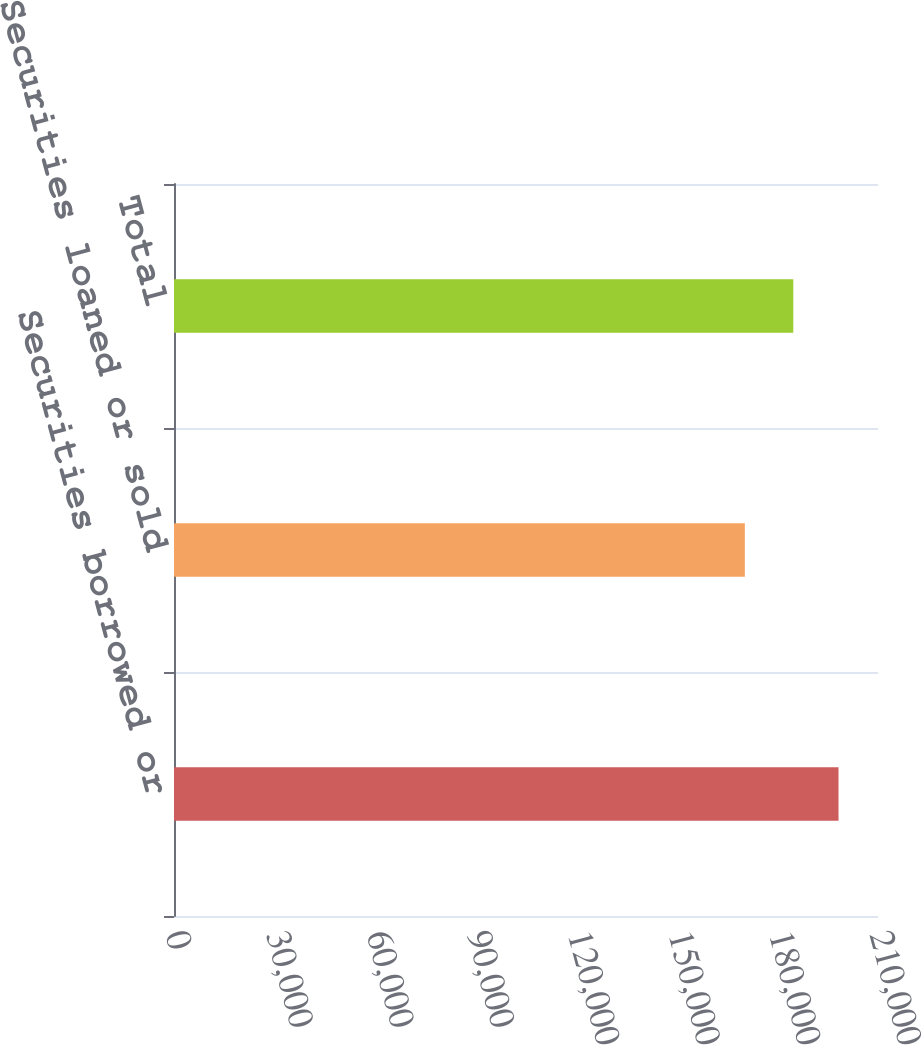Convert chart. <chart><loc_0><loc_0><loc_500><loc_500><bar_chart><fcel>Securities borrowed or<fcel>Securities loaned or sold<fcel>Total<nl><fcel>198224<fcel>170282<fcel>184730<nl></chart> 